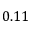<formula> <loc_0><loc_0><loc_500><loc_500>0 . 1 1</formula> 